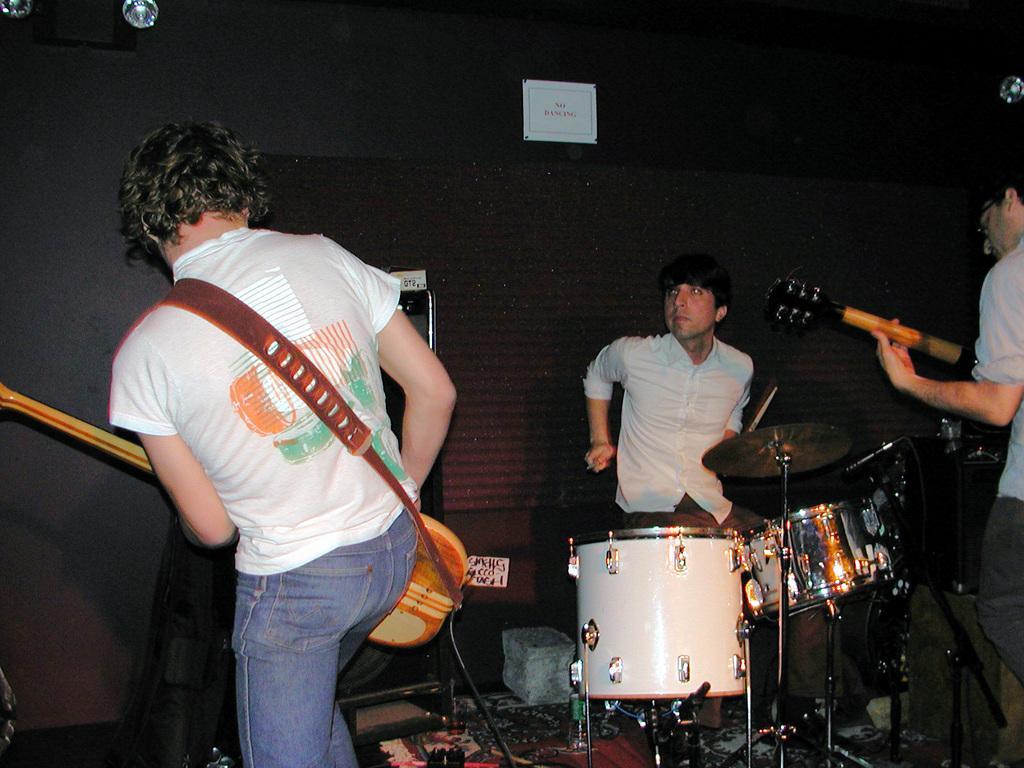How would you summarize this image in a sentence or two? Here we can see three men on the platform and playing musical instruments. They all are in white colour shirts. This is a paper note on the background. These are lights. 